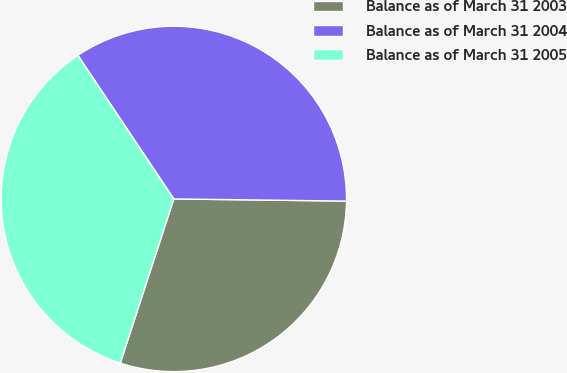Convert chart. <chart><loc_0><loc_0><loc_500><loc_500><pie_chart><fcel>Balance as of March 31 2003<fcel>Balance as of March 31 2004<fcel>Balance as of March 31 2005<nl><fcel>29.82%<fcel>34.58%<fcel>35.61%<nl></chart> 